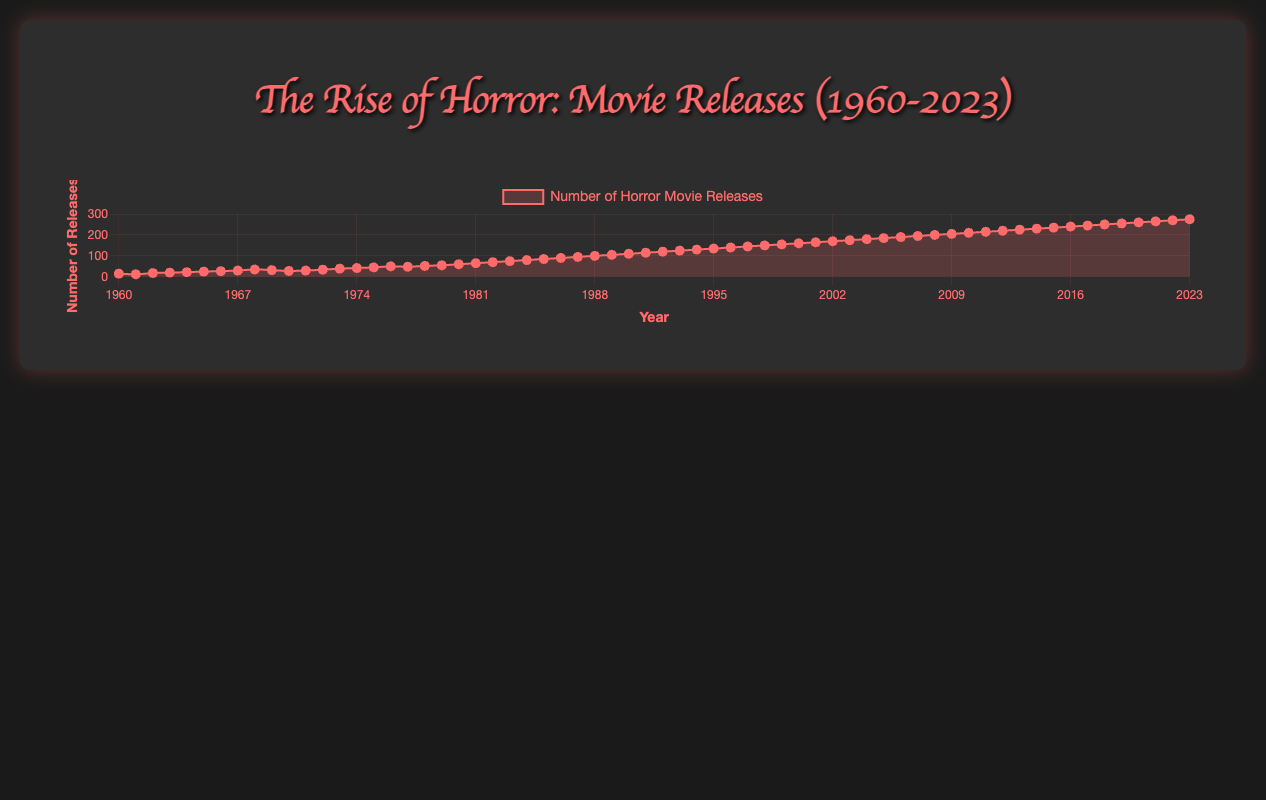What year saw the beginning of a consistent increase in horror movie releases? The consistent increase in horror movie releases can be observed starting from the early 1980s. By examining the plot, there is a noticeable upward trend starting around 1980 and continuing steadily onwards.
Answer: 1980 Which decade experienced the highest growth in horror movie releases compared to the previous decade? Comparing the number of releases at the start and end of each decade, the 1980s experienced a significant increase. In 1980, there were 60 releases, and in 1989, there were 105 releases. The difference is 45 movies, which is higher than increases in previous decades.
Answer: 1980s Between 2000 and 2010, how many more horror movies were released in 2010 compared to 2000? In 2000 there were 160 releases, and in 2010 there were 210 releases. By subtracting 160 from 210, we get the number of additional releases.
Answer: 50 Which year had more horror movie releases: 1970 or 1980? By comparing the data points, 1970 had 28 releases, while 1980 had 60 releases. Therefore, 1980 had more releases.
Answer: 1980 What was the average number of horror movie releases per year in the 1960s? To find the average, sum up the releases from 1960 to 1969 and divide by the number of years (10). The total number of releases in the 1960s is 15+12+18+20+22+25+27+30+35+32 = 236. The average is 236 / 10 = 23.6
Answer: 23.6 Is the rate of increase in horror movie releases higher in the 2000s or the 1980s? By calculating the change in the number of releases over each decade: 1980s increased from 60 to 105 (45 more releases), and the 2000s increased from 160 to 210 (50 more releases). Thus, the rate of increase is higher in the 2000s.
Answer: 2000s Between 1965 and 1975, which year had the peak number of horror movie releases and how many releases were there? Looking at the data from 1965 to 1975, the year 1975 saw the peak with 45 releases.
Answer: 1975, 45 What is the growth rate of horror movie releases from 1960 to 2020? To calculate the growth rate, we subtract the number of releases in 1960 (15) from the number in 2020 (260), and then divide by the number of years (2020 - 1960 = 60 years). Growth rate = (260 - 15) / 60 = 4.083.
Answer: 4.083 What is the percentage increase in horror movie releases from 1980 to 2020? First, calculate the increase in releases from 1980 (60) to 2020 (260). The increase is 260 - 60 = 200. Then, calculate the percentage increase as (200 / 60) * 100 = 333.33%.
Answer: 333.33% 